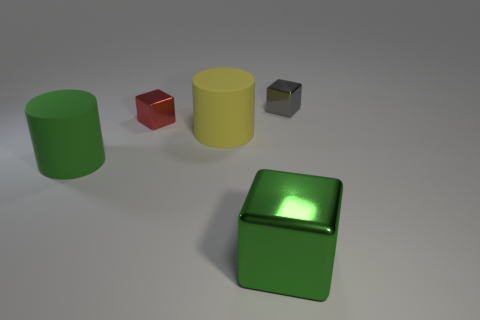What does the placement of these objects tell us? The objects are dispersed with ample space between each other, placed seemingly at random on a neutral surface. This arrangement might suggest an intentional setup, perhaps for the purpose of showcasing their shapes, colors, and textures as part of a study or for a visual effect.  Are there any shadows or indications of a light source? Indeed, there are subtle shadows cast by each object, indicating that the light source is coming from the upper left-hand side of the frame. The shadows help to give a sense of the dimensionality and the position of the objects in the physical space. 